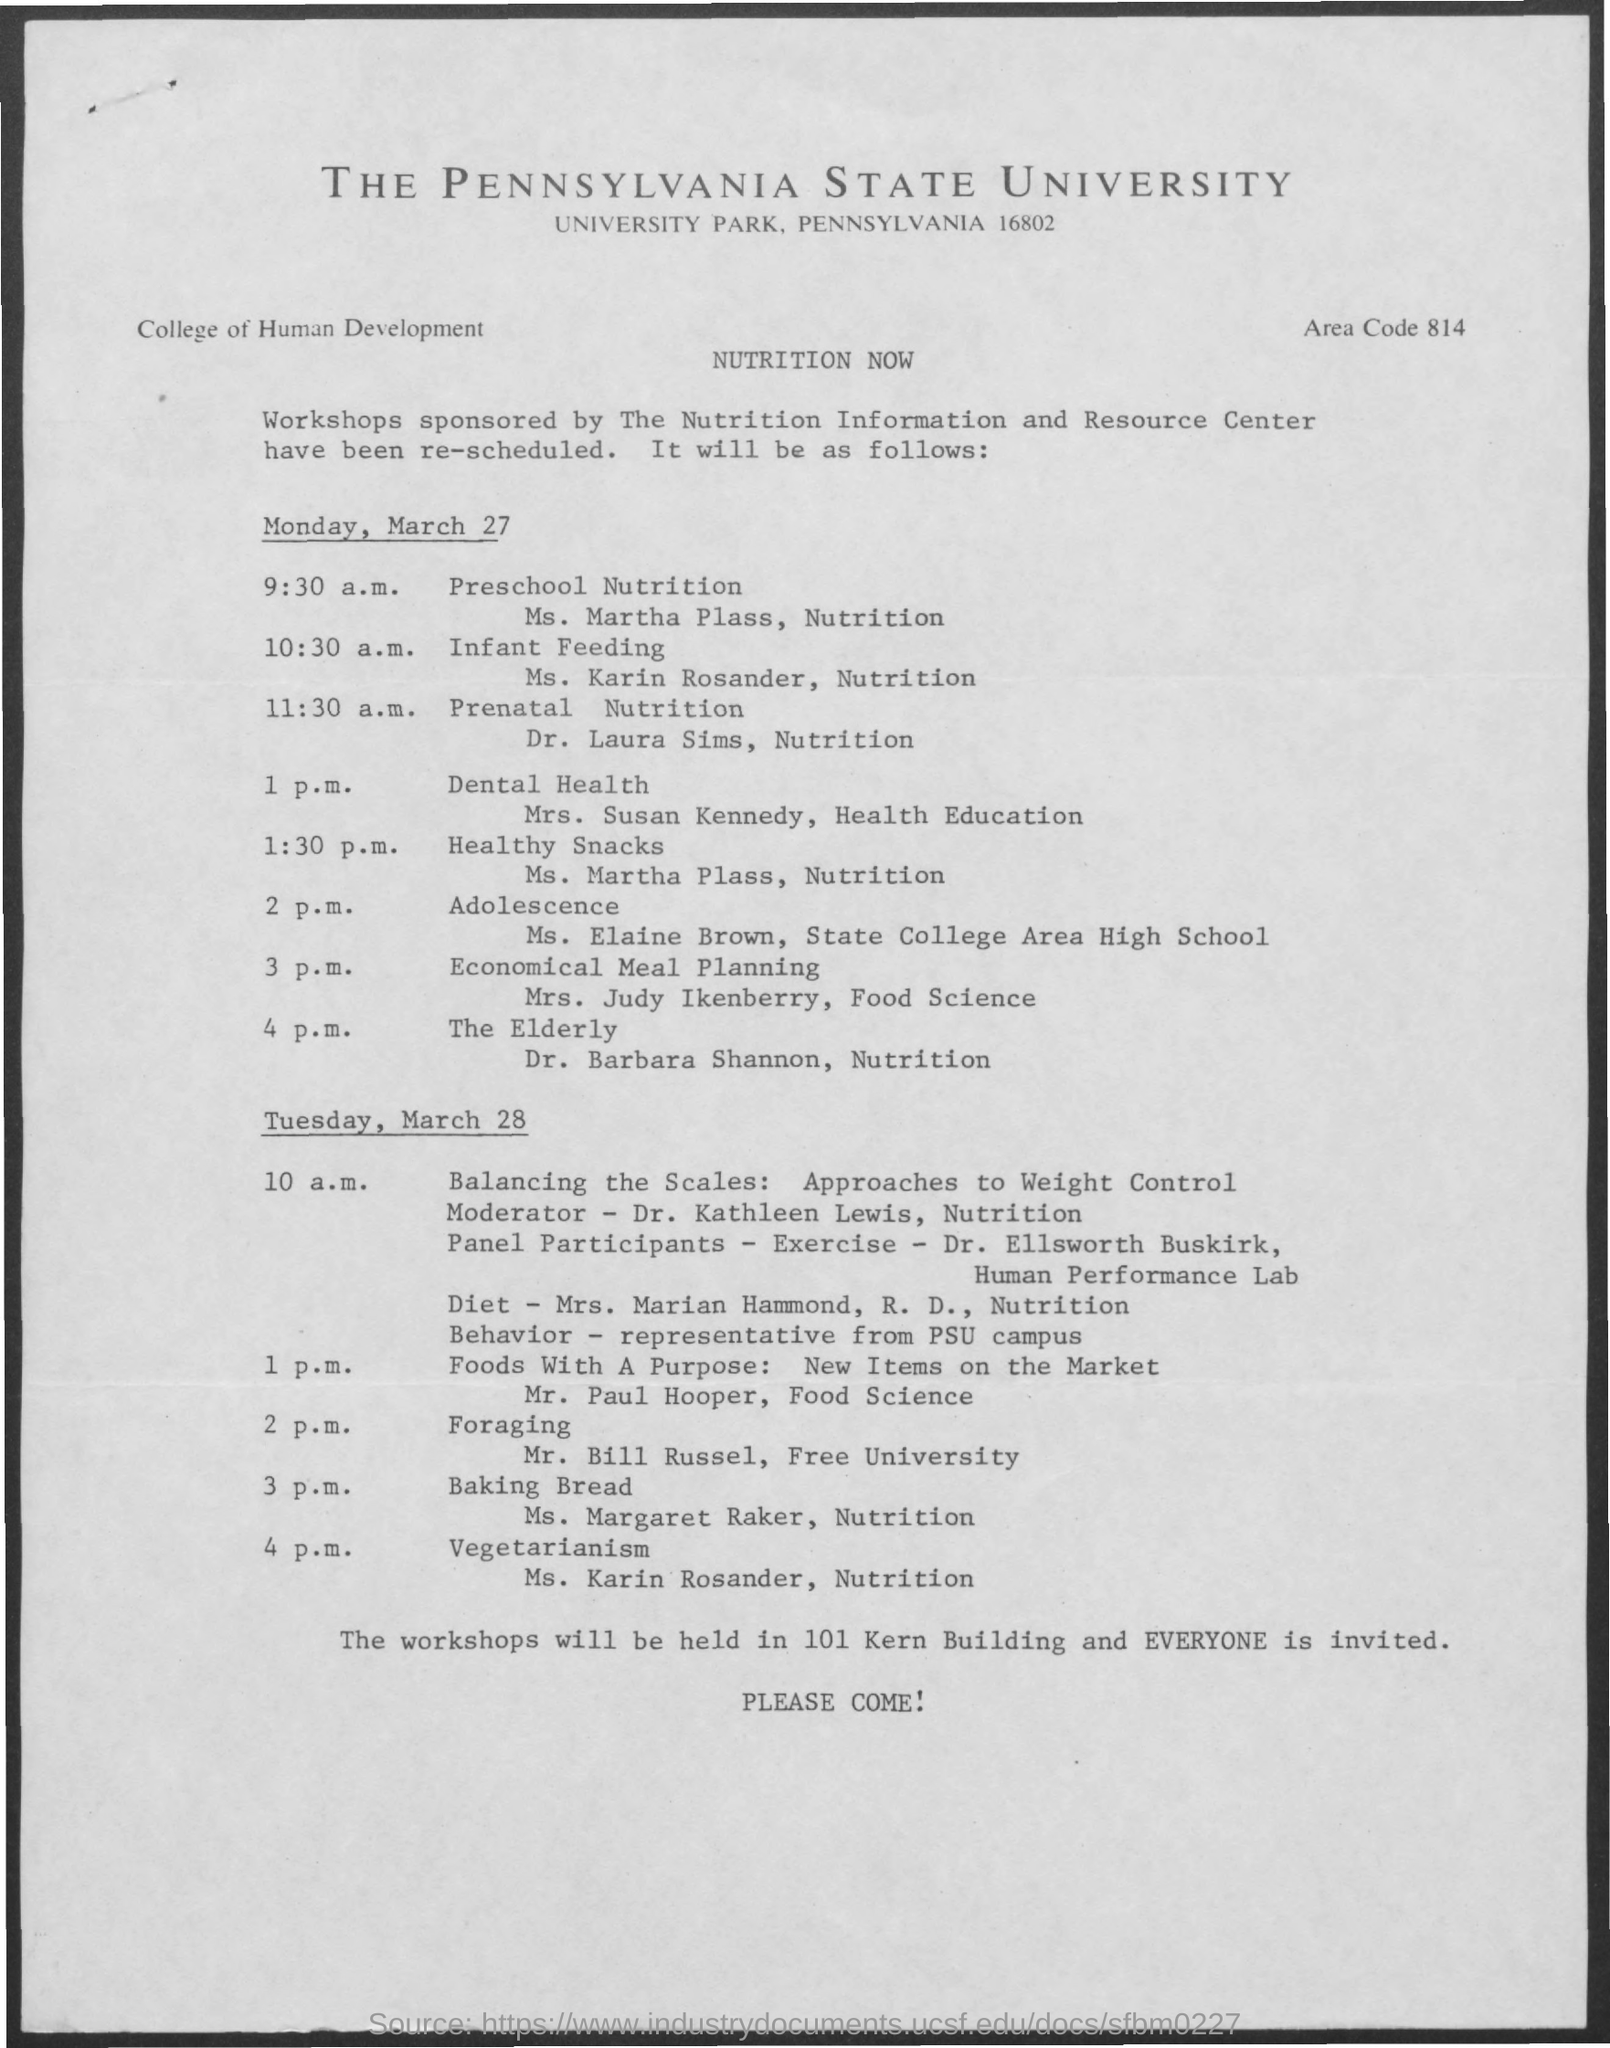Identify some key points in this picture. At 2 pm on Tuesday, March 28th, the schedule is as follows: Foraging. The area code mentioned on the given page is 814. At 1:30 pm on Monday, March 27, the schedule is as follows: healthy snacks. The workshops will be conducted in the 101 Kern Building. The scheduled time for preschool nutrition is 9:30 a.m. 